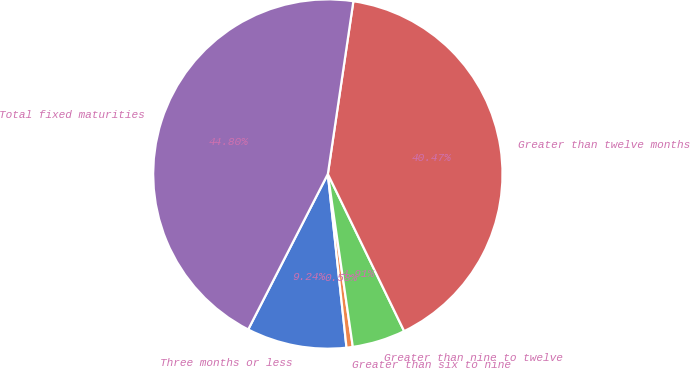Convert chart to OTSL. <chart><loc_0><loc_0><loc_500><loc_500><pie_chart><fcel>Three months or less<fcel>Greater than six to nine<fcel>Greater than nine to twelve<fcel>Greater than twelve months<fcel>Total fixed maturities<nl><fcel>9.24%<fcel>0.58%<fcel>4.91%<fcel>40.47%<fcel>44.8%<nl></chart> 